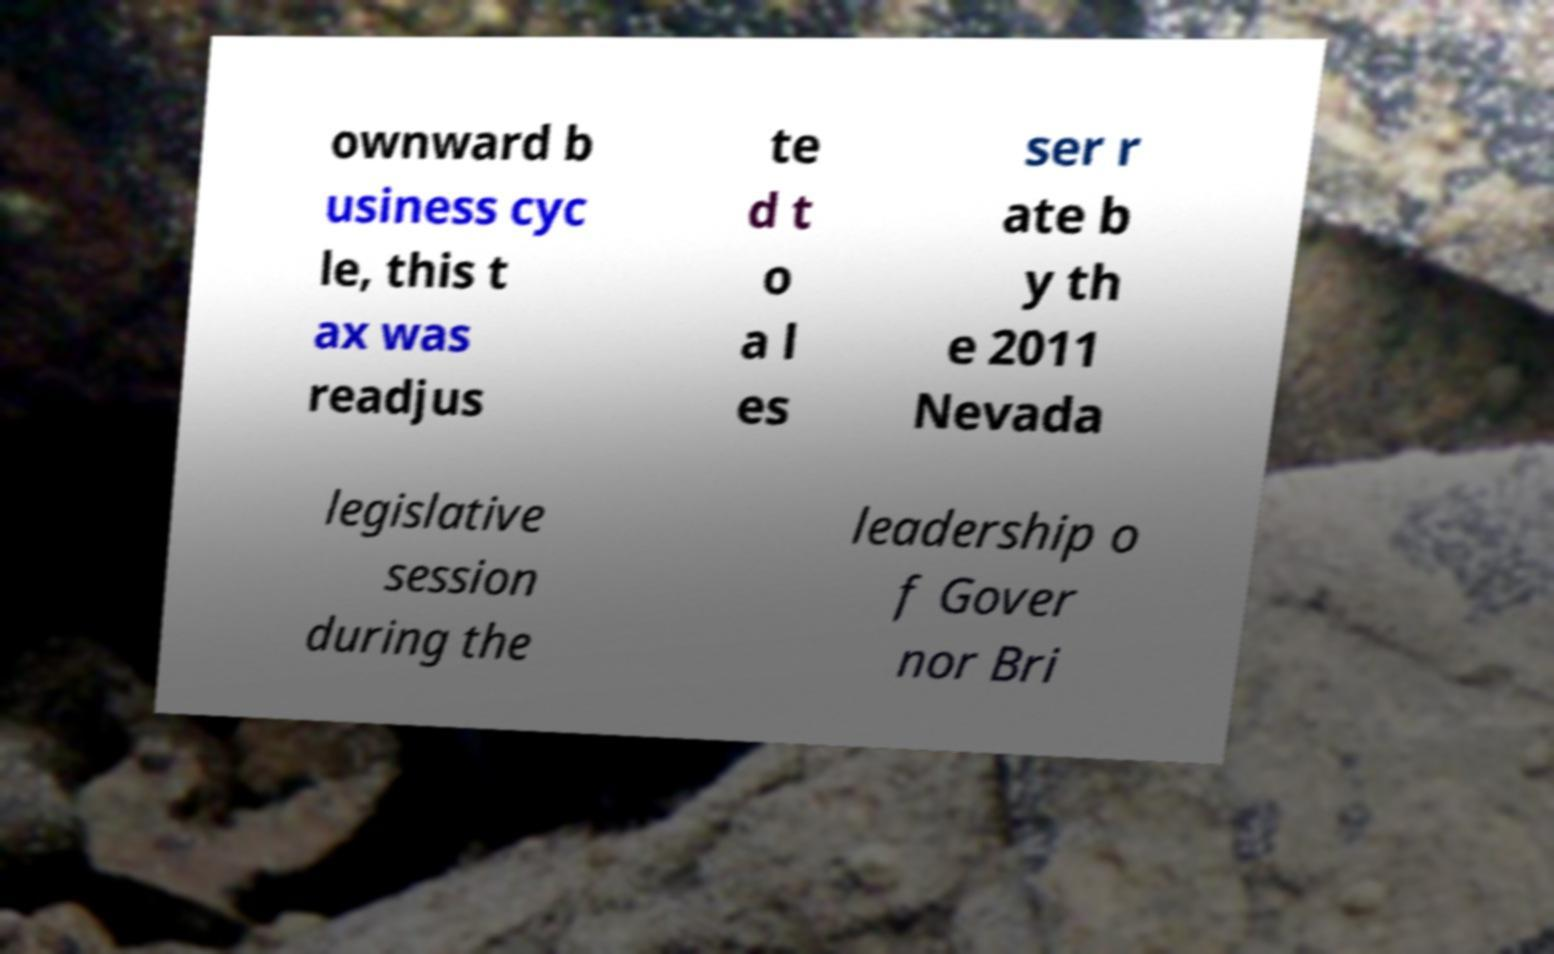Please identify and transcribe the text found in this image. ownward b usiness cyc le, this t ax was readjus te d t o a l es ser r ate b y th e 2011 Nevada legislative session during the leadership o f Gover nor Bri 